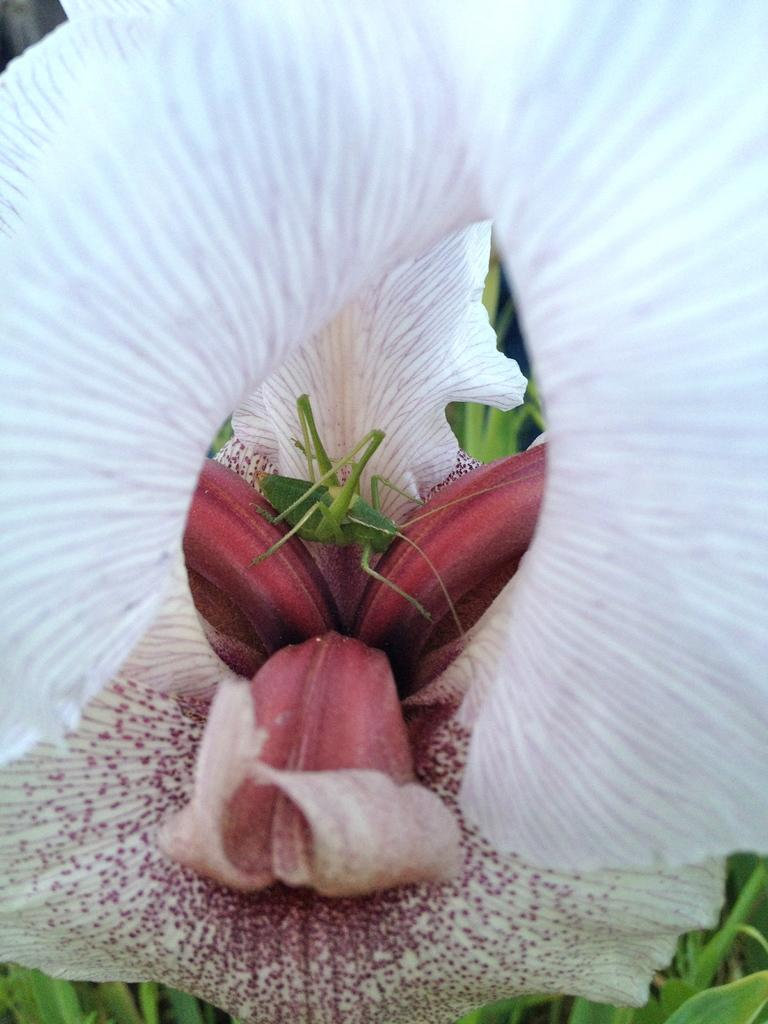What type of flower is present in the image? There is a white and peach color flower in the image. Can you describe any other living organisms in the image? There is a green color insect inside the flower. What type of vegetation can be seen in the image besides the flower? There are green leaves visible in the image. What type of sweater is the visitor wearing in the image? There is no visitor or sweater present in the image; it features a flower and an insect. What type of oil can be seen dripping from the flower in the image? There is no oil present in the image; it features a flower, an insect, and green leaves. 